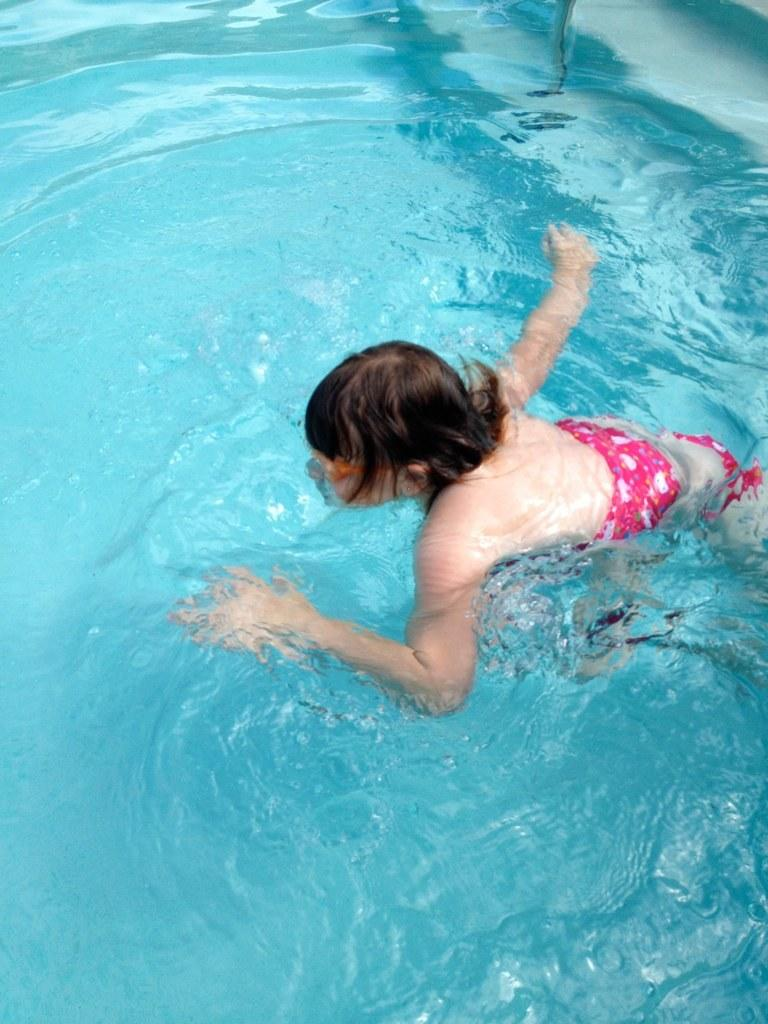Who is present in the image? There is a person in the image. What is the person doing in the image? The person is swimming in the image. Where is the person swimming? The person is swimming in a swimming pool. What type of dinner is being served on the cart in the image? There is no cart or dinner present in the image; it features a person swimming in a swimming pool. 